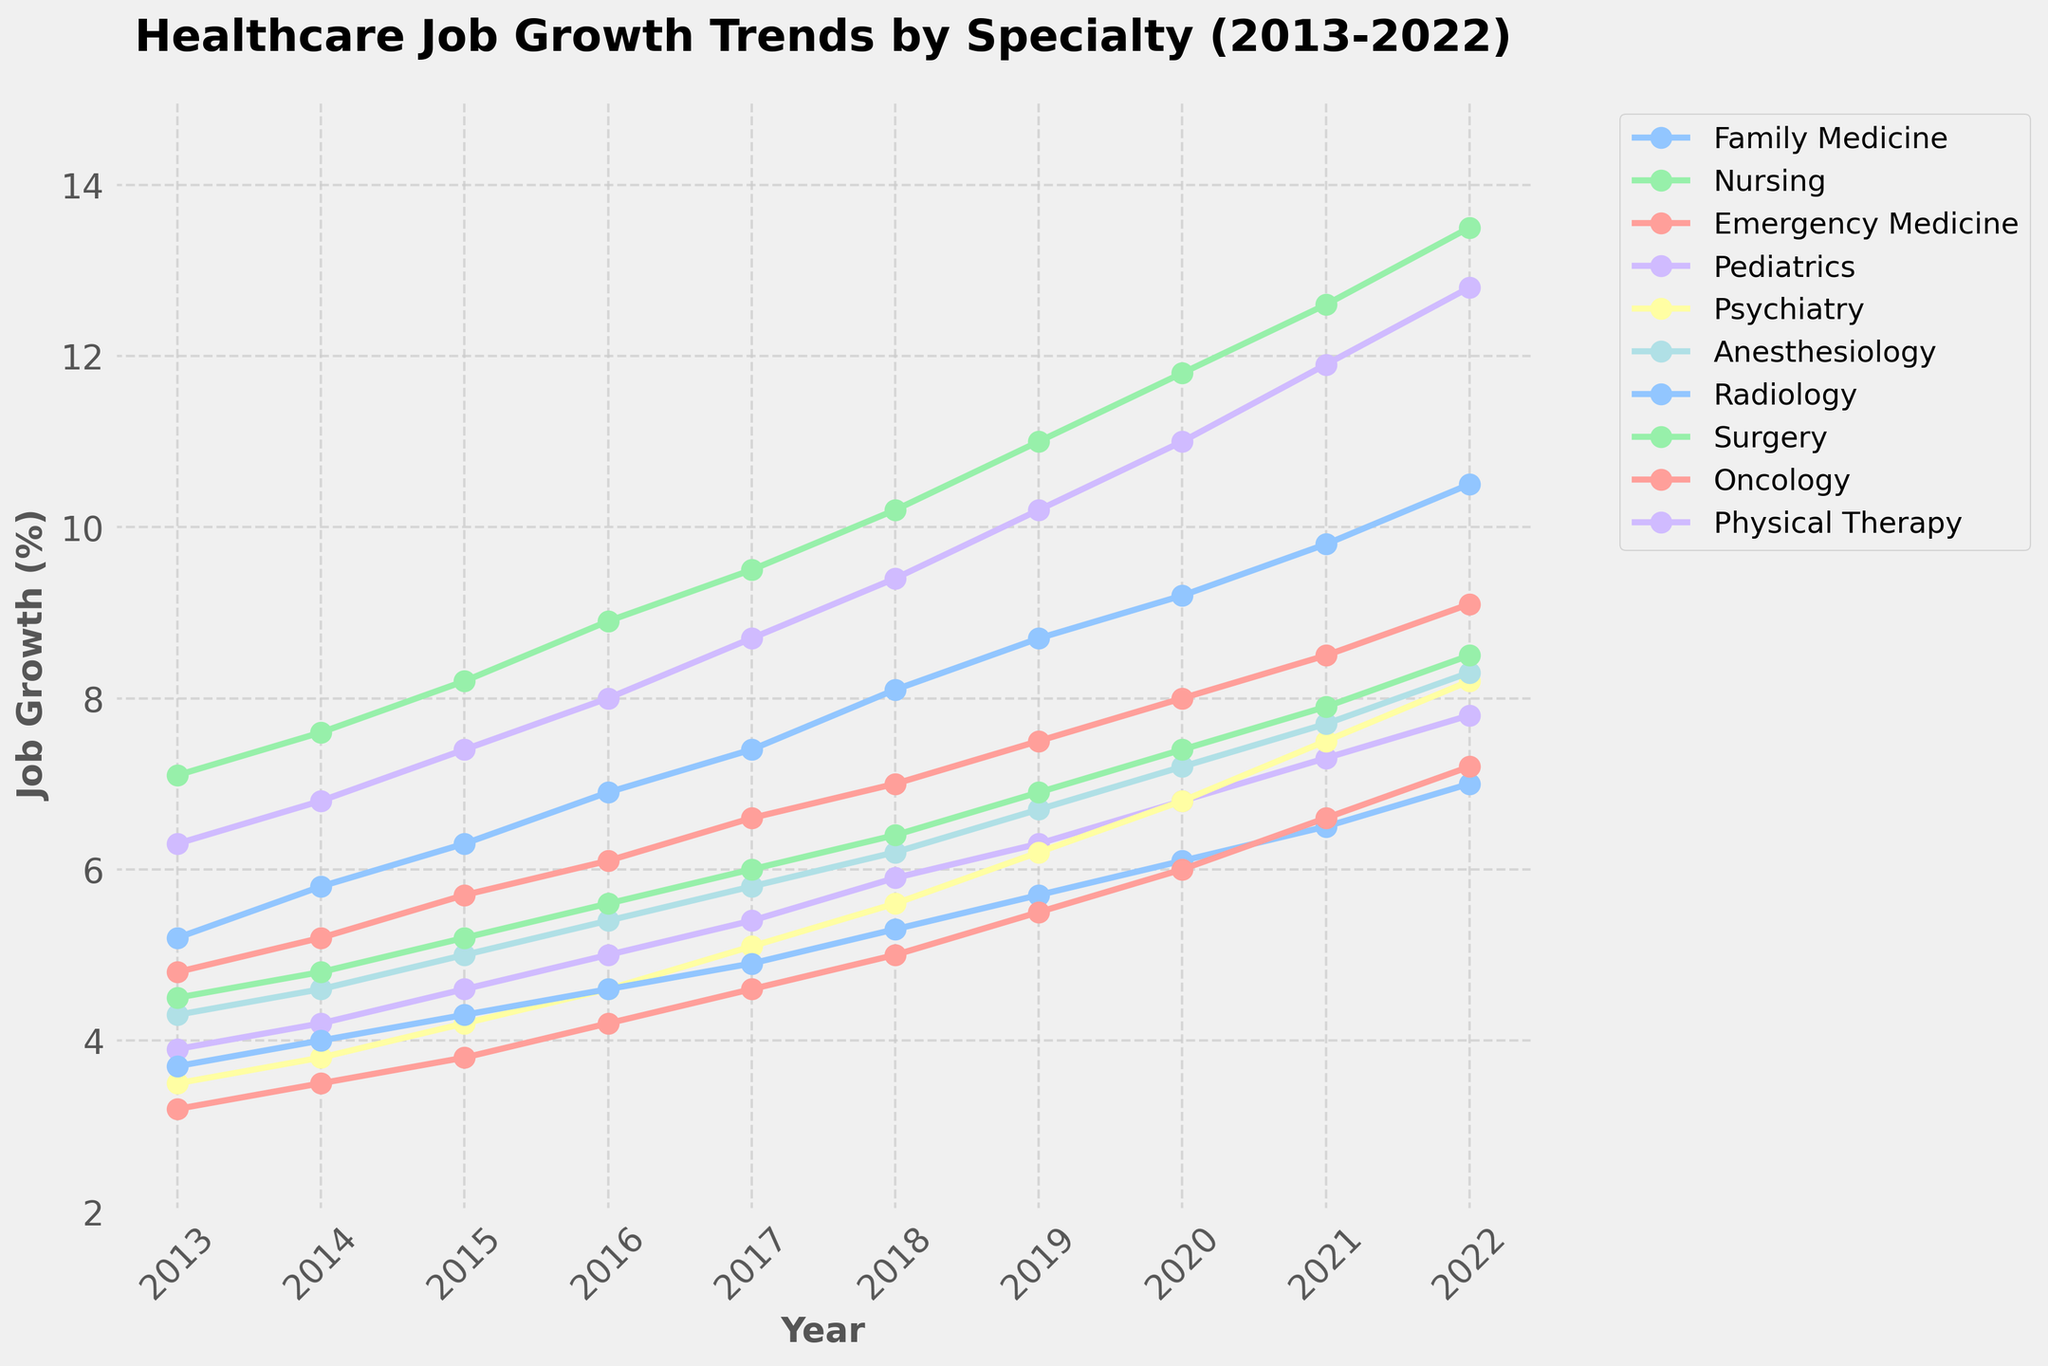What medical specialty had the highest job growth in 2022? To find the highest job growth in 2022, look at the end points for all specialties on the right side of the chart. Compare the values for each specialty. Nursing had the highest value at 13.5%
Answer: Nursing How much did Physical Therapy job growth increase from 2013 to 2022? To find the increase, subtract the 2013 value from the 2022 value for Physical Therapy. The values are 12.8% in 2022 and 6.3% in 2013. So, 12.8 - 6.3 = 6.5%
Answer: 6.5% Which specialty saw the smallest job growth in 2016? To determine the smallest job growth in 2016, compare the mid-point values for all specialties. Oncology had the lowest value at 4.2%
Answer: Oncology Did any specialties have equal job growth in any given year, and if so, which ones and in what year? Check across all years to see if any specialties share the same job growth percentage within the same year. In 2013, both Radiology and Pediatrics had the same job growth of 3.7%
Answer: Radiology and Pediatrics in 2013 What is the average job growth of Nursing from 2013 to 2022? Add up the job growth values for Nursing from 2013 to 2022 and divide by the number of years (10). Values are 7.1, 7.6, 8.2, 8.9, 9.5, 10.2, 11.0, 11.8, 12.6, 13.5. Sum = 100.4, so the average is 100.4/10 = 10.04%
Answer: 10.04% Which specialties showed a consistent increase in job growth every year without any declines? Examine the trend lines for all specialties to identify those with continuous increments each year. All listed specialties (Family Medicine, Nursing, Emergency Medicine, Pediatrics, Psychiatry, Anesthesiology, Radiology, Surgery, Oncology, Physical Therapy) show a consistent increase every year.
Answer: All specialties Compare the job growth of Family Medicine and Physical Therapy in 2020. Which one had a higher growth rate? Look at the job growth values for both Family Medicine and Physical Therapy in 2020. Family Medicine had 9.2% and Physical Therapy had 11.0%. Physical Therapy had a higher growth rate.
Answer: Physical Therapy What is the cumulative job growth of Surgery over the decade (2013-2022)? Add the annual job growth rates for Surgery from 2013 to 2022. Values are 4.5, 4.8, 5.2, 5.6, 6.0, 6.4, 6.9, 7.4, 7.9, 8.5. Sum = 63.2%.
Answer: 63.2% Which specialty has the steepest growth curve from 2013 to 2022? The steepest growth curve is identified by the most significant increase over time. Comparing the slopes, Nursing’s growth from 7.1% to 13.5% shows the steepest increase.
Answer: Nursing 